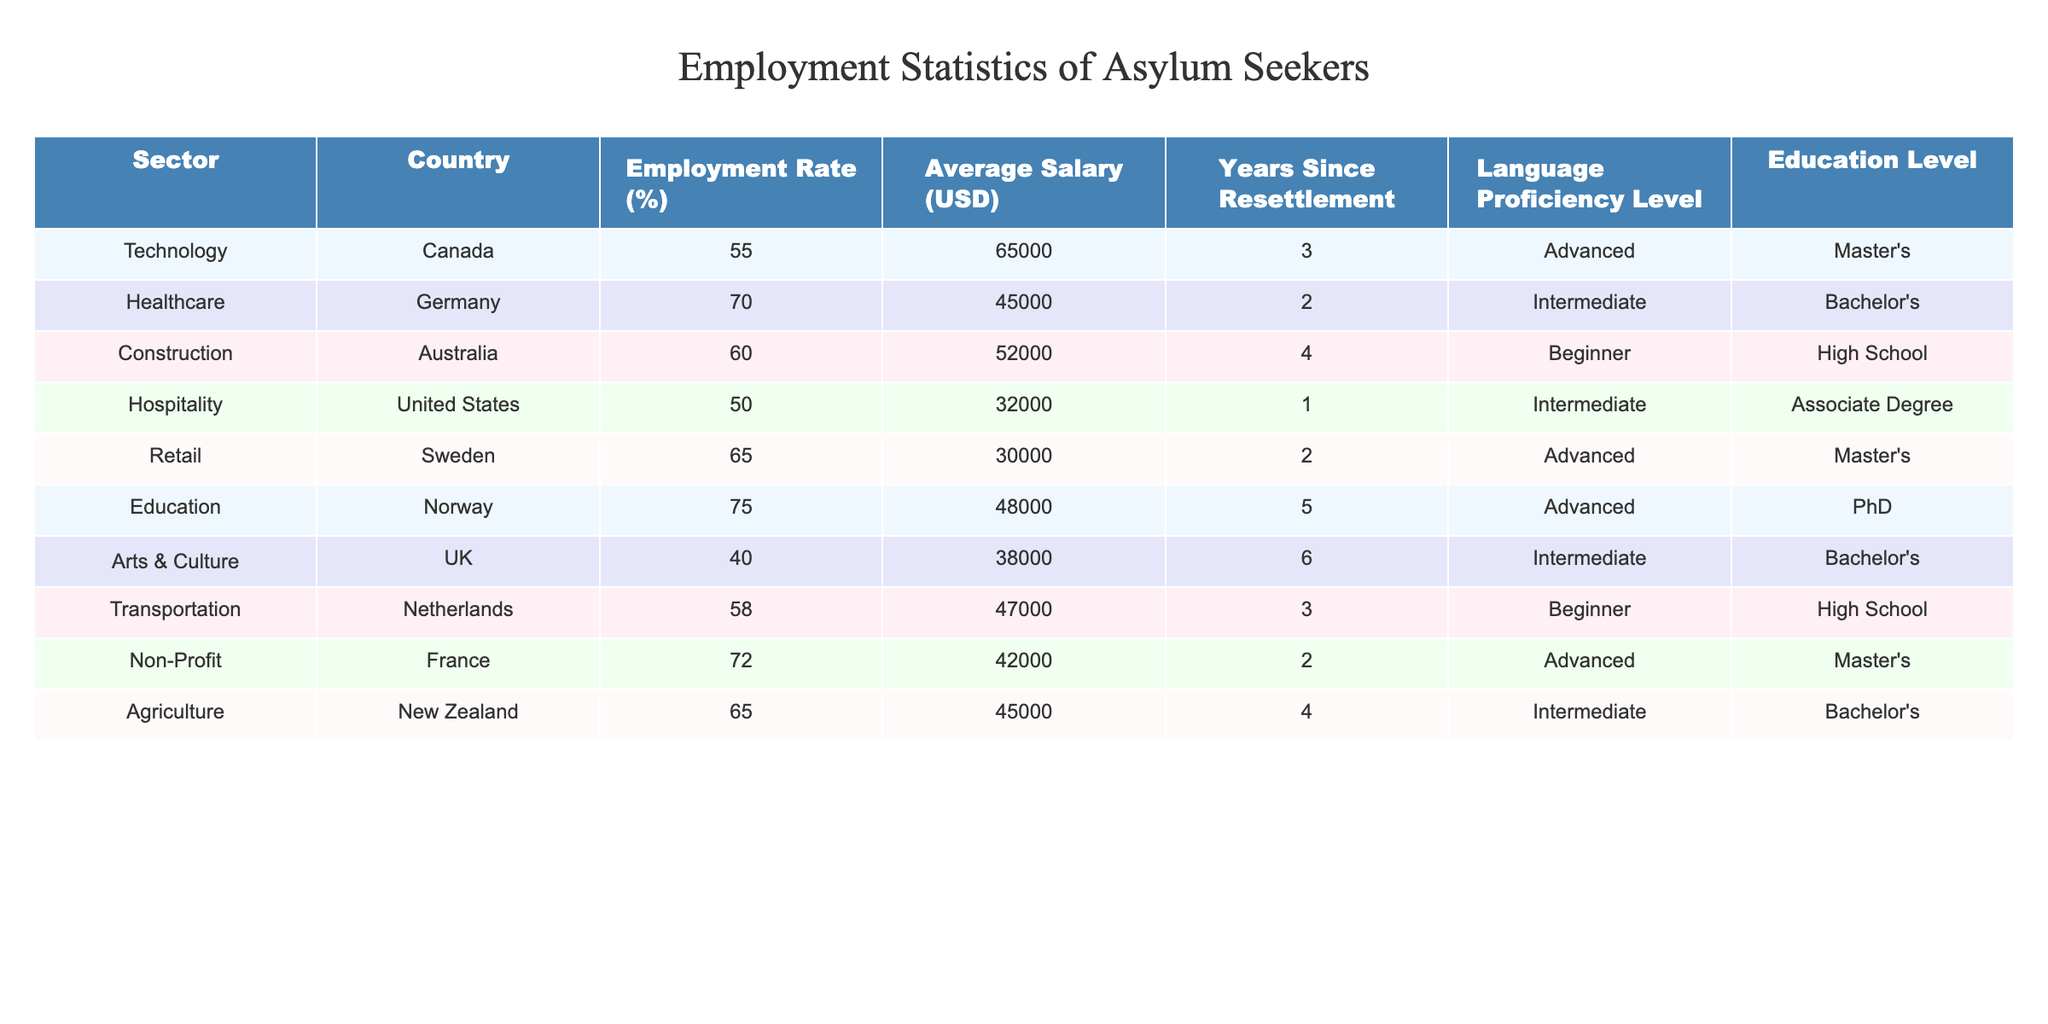What is the employment rate for asylum seekers in the Healthcare sector in Germany? The table shows that the Employment Rate for the Healthcare sector in Germany is listed as 70%.
Answer: 70% Which country has the highest employment rate for asylum seekers in the table? The highest employment rate is in Norway for the Education sector, where the rate is 75%.
Answer: Norway What is the average salary for asylum seekers working in the Technology sector? The table states that the average salary for the Technology sector in Canada is $65,000.
Answer: 65000 Is the employment rate for asylum seekers in the Arts & Culture sector greater than 50%? The table shows the Employment Rate for the Arts & Culture sector in the UK is 40%, which is less than 50%. Therefore, the statement is false.
Answer: No What is the difference in average salary between the highest and lowest paying sectors? The highest average salary is in the Technology sector ($65,000) and the lowest is in the Hospitality sector ($32,000). The difference is $65,000 - $32,000 = $33,000.
Answer: 33000 What percentage of asylum seekers in the Non-Profit sector report an Advanced language proficiency level? The table indicates that asylum seekers in the Non-Profit sector in France report an Advanced language proficiency level, which is 100% of those in that sector.
Answer: 100% What is the median employment rate for the sectors listed in the table? The employment rates are 55%, 70%, 60%, 50%, 65%, 75%, 40%, 58%, 72%, and 65%. Sorting these rates gives: 40%, 50%, 55%, 58%, 60%, 65%, 65%, 70%, 72%, 75%. The median (middle value) is the average of the 5th and 6th values: (60% + 65%) / 2 = 62.5%.
Answer: 62.5% Which sector has the longest average number of years since resettlement for asylum seekers? The Education sector in Norway lists an average of 5 years since resettlement, which is the longest compared to other sectors in the table.
Answer: Education sector Is there a correlation between language proficiency level and employment rate for asylum seekers across the sectors? To determine correlation, we would analyze the employment rates and corresponding language proficiency levels. Upon inspection, Advanced proficiency is associated with higher employment rates (70%-75%), indicating a positive correlation but a full analysis may require further statistical measures.
Answer: Yes In how many sectors is the average salary above $45,000? The sectors with average salaries above $45,000 are Technology ($65,000), Healthcare ($45,000), and Agriculture ($45,000). Counting these, there are 5 such sectors.
Answer: 5 